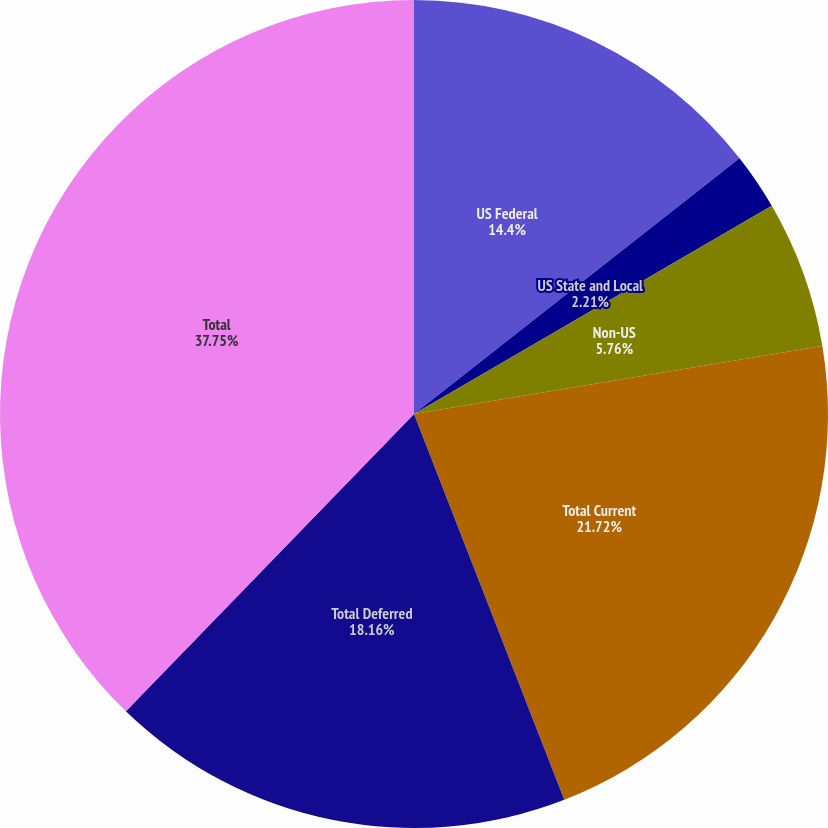Convert chart to OTSL. <chart><loc_0><loc_0><loc_500><loc_500><pie_chart><fcel>US Federal<fcel>US State and Local<fcel>Non-US<fcel>Total Current<fcel>Total Deferred<fcel>Total<nl><fcel>14.4%<fcel>2.21%<fcel>5.76%<fcel>21.72%<fcel>18.16%<fcel>37.75%<nl></chart> 